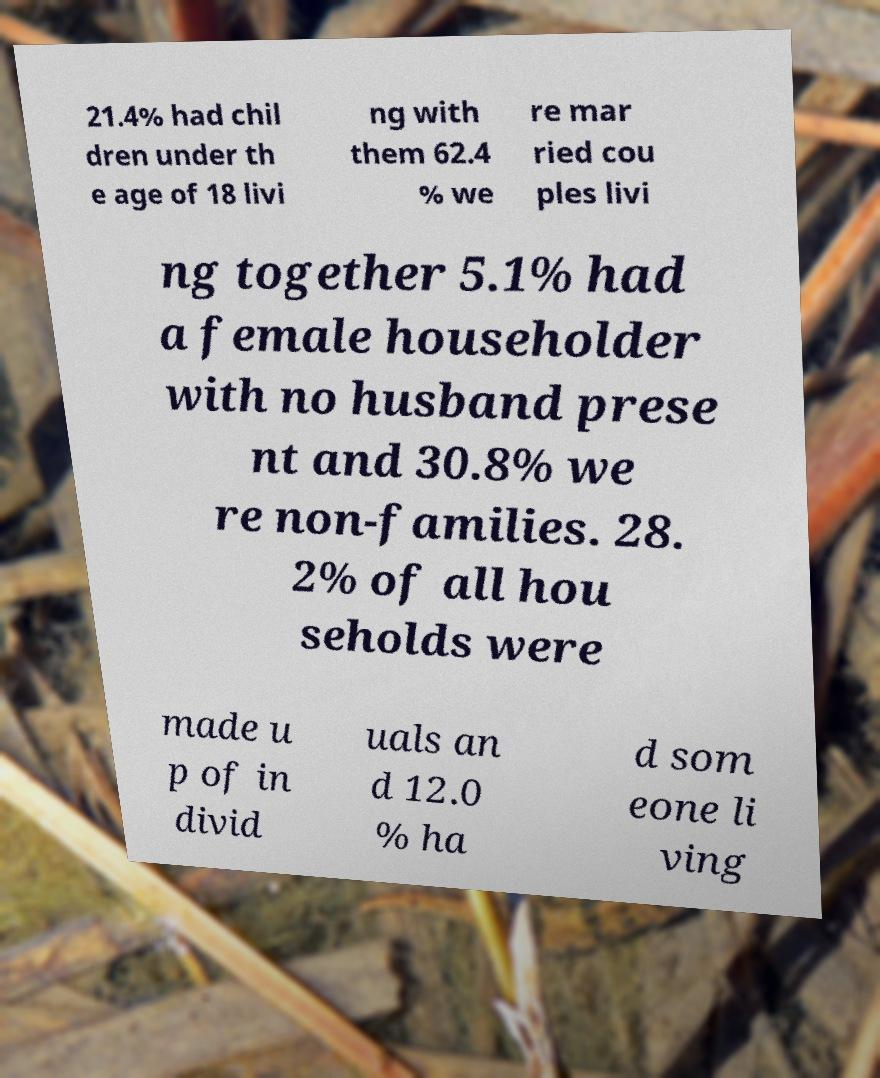Could you extract and type out the text from this image? 21.4% had chil dren under th e age of 18 livi ng with them 62.4 % we re mar ried cou ples livi ng together 5.1% had a female householder with no husband prese nt and 30.8% we re non-families. 28. 2% of all hou seholds were made u p of in divid uals an d 12.0 % ha d som eone li ving 